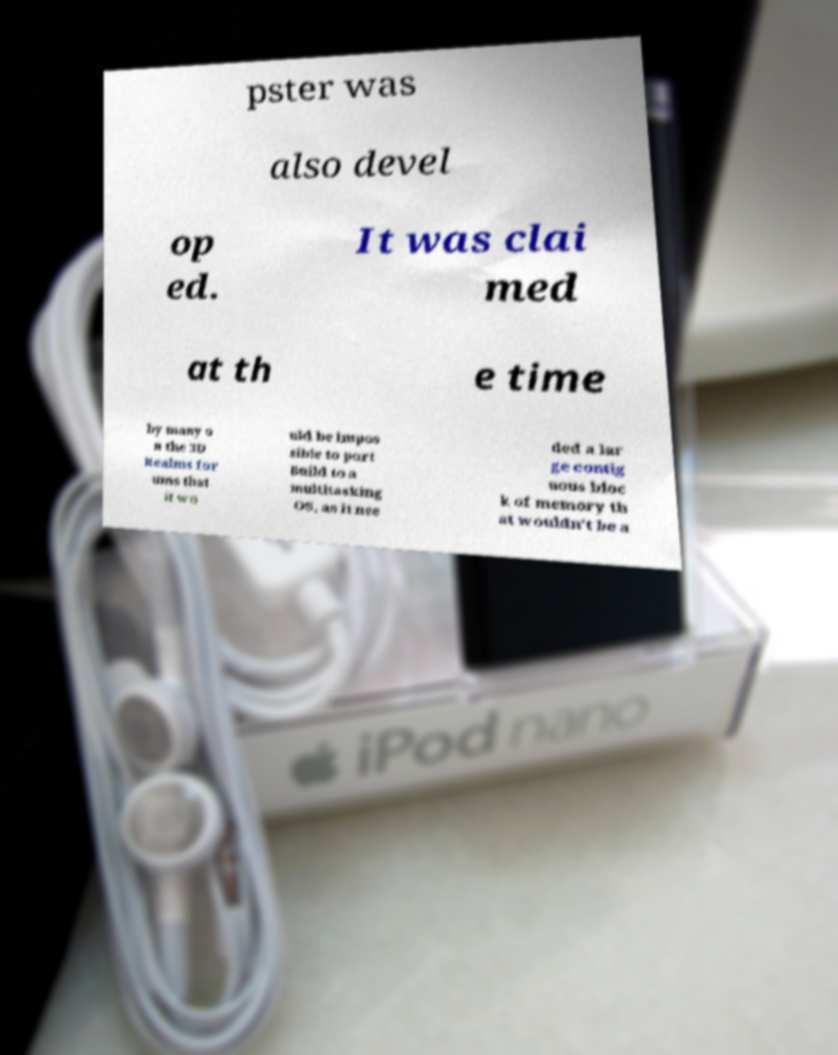Could you extract and type out the text from this image? pster was also devel op ed. It was clai med at th e time by many o n the 3D Realms for ums that it wo uld be impos sible to port Build to a multitasking OS, as it nee ded a lar ge contig uous bloc k of memory th at wouldn't be a 